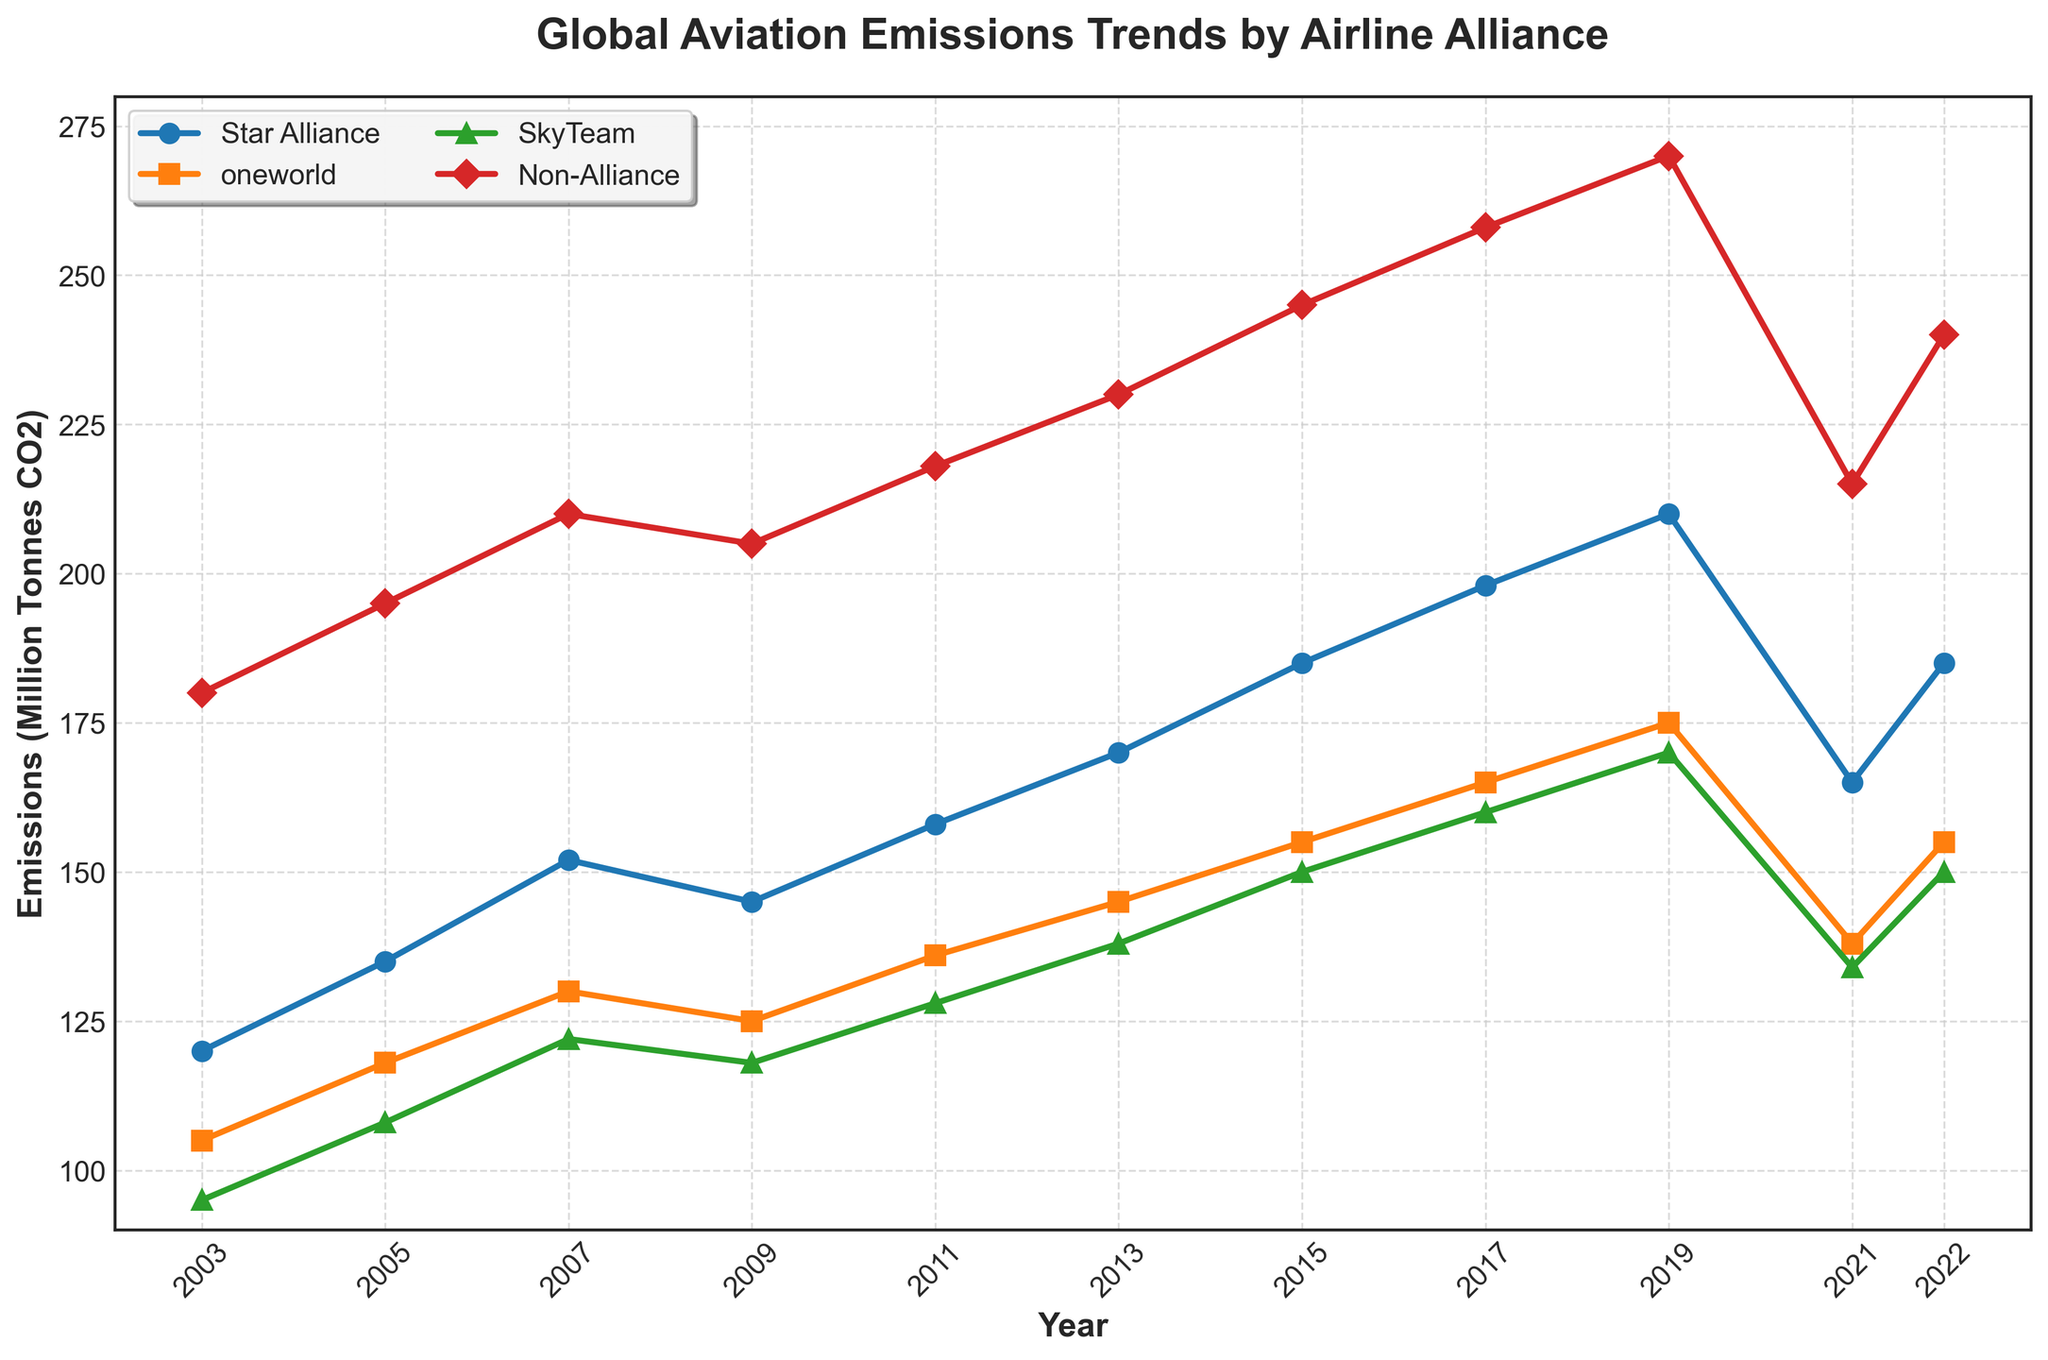Which alliance showed the highest emissions in 2019? Looking at the line chart, the "Non-Alliance" line reaches the highest point in 2019 compared to other alliances.
Answer: Non-Alliance Which alliance had the most significant drop in emissions between 2019 and 2021? By comparing the steepness between 2019 and 2021, the "Star Alliance" line shows a significant decline.
Answer: Star Alliance What is the combined emission value for all alliances in 2021? Sum the emission values for all alliances in 2021: 165 (Star Alliance) + 138 (oneworld) + 134 (SkyTeam) + 215 (Non-Alliance) = 652 million tonnes CO2.
Answer: 652 Which year did SkyTeam and oneworld have an equal emission value, if ever? By examining the lines for SkyTeam and oneworld, they never intersect, indicating unequal emissions each year.
Answer: Never In what year did Star Alliance surpass the 150 million tonnes CO2 emission mark for the first time? The "Star Alliance" line first surpasses 150 million tonnes between 2007 and 2009; checking exact data, this happens in 2007.
Answer: 2007 Did any alliance have lower emissions in 2022 compared to 2003? Comparing data points of 2022 and 2003 for each alliance, no alliance has lower emissions in 2022.
Answer: No Which alliance has the flattest trend line indicating the slowest growth over the 20 years? The "SkyTeam" line shows the flattest growth compared to others.
Answer: SkyTeam What was the maximum emission value reached by oneworld during the 20-year period? The highest point on the "oneworld" line is in 2019, peaking at 175 million tonnes CO2.
Answer: 175 How much did Non-Alliance emissions increase from 2003 to 2019? Subtract the 2003 value from 2019 for Non-Alliance: 270 - 180 = 90 million tonnes CO2 increase.
Answer: 90 How many times did emissions drop for Star Alliance throughout the 20-year period shown? Observing the Star Alliance line, emissions dropped in 2009 and 2021, indicating two drops.
Answer: 2 